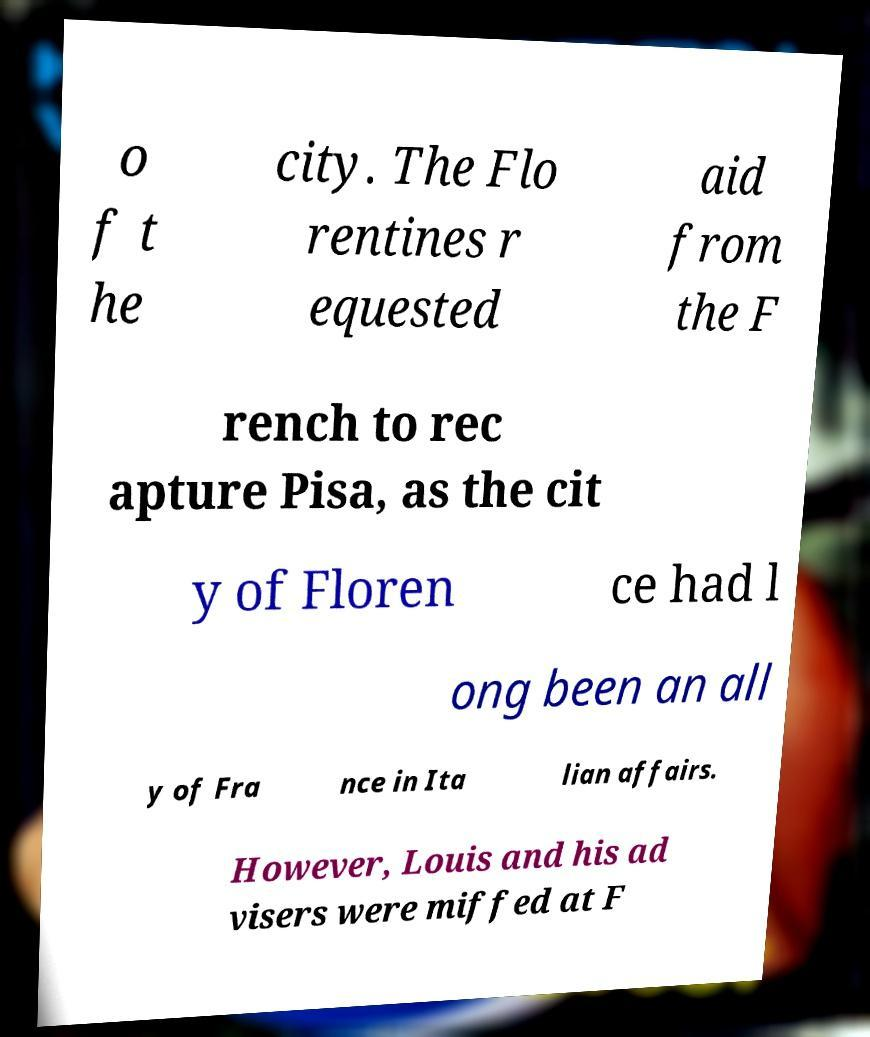Please read and relay the text visible in this image. What does it say? o f t he city. The Flo rentines r equested aid from the F rench to rec apture Pisa, as the cit y of Floren ce had l ong been an all y of Fra nce in Ita lian affairs. However, Louis and his ad visers were miffed at F 